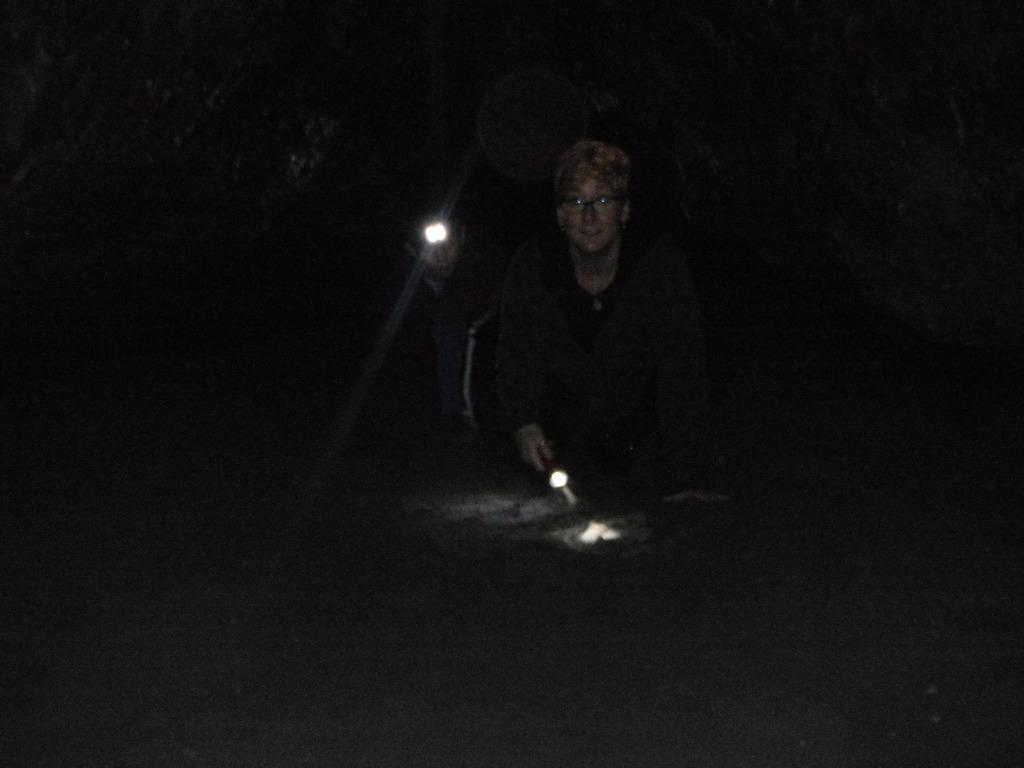How many people are in the image? There are two persons in the image. What are the persons holding in the image? The persons are holding lights. Can you describe the lighting conditions in the image? The image appears to be in a dark setting. How many horses are present in the image? There are no horses present in the image. What type of surprise can be seen in the image? There is no surprise visible in the image. 